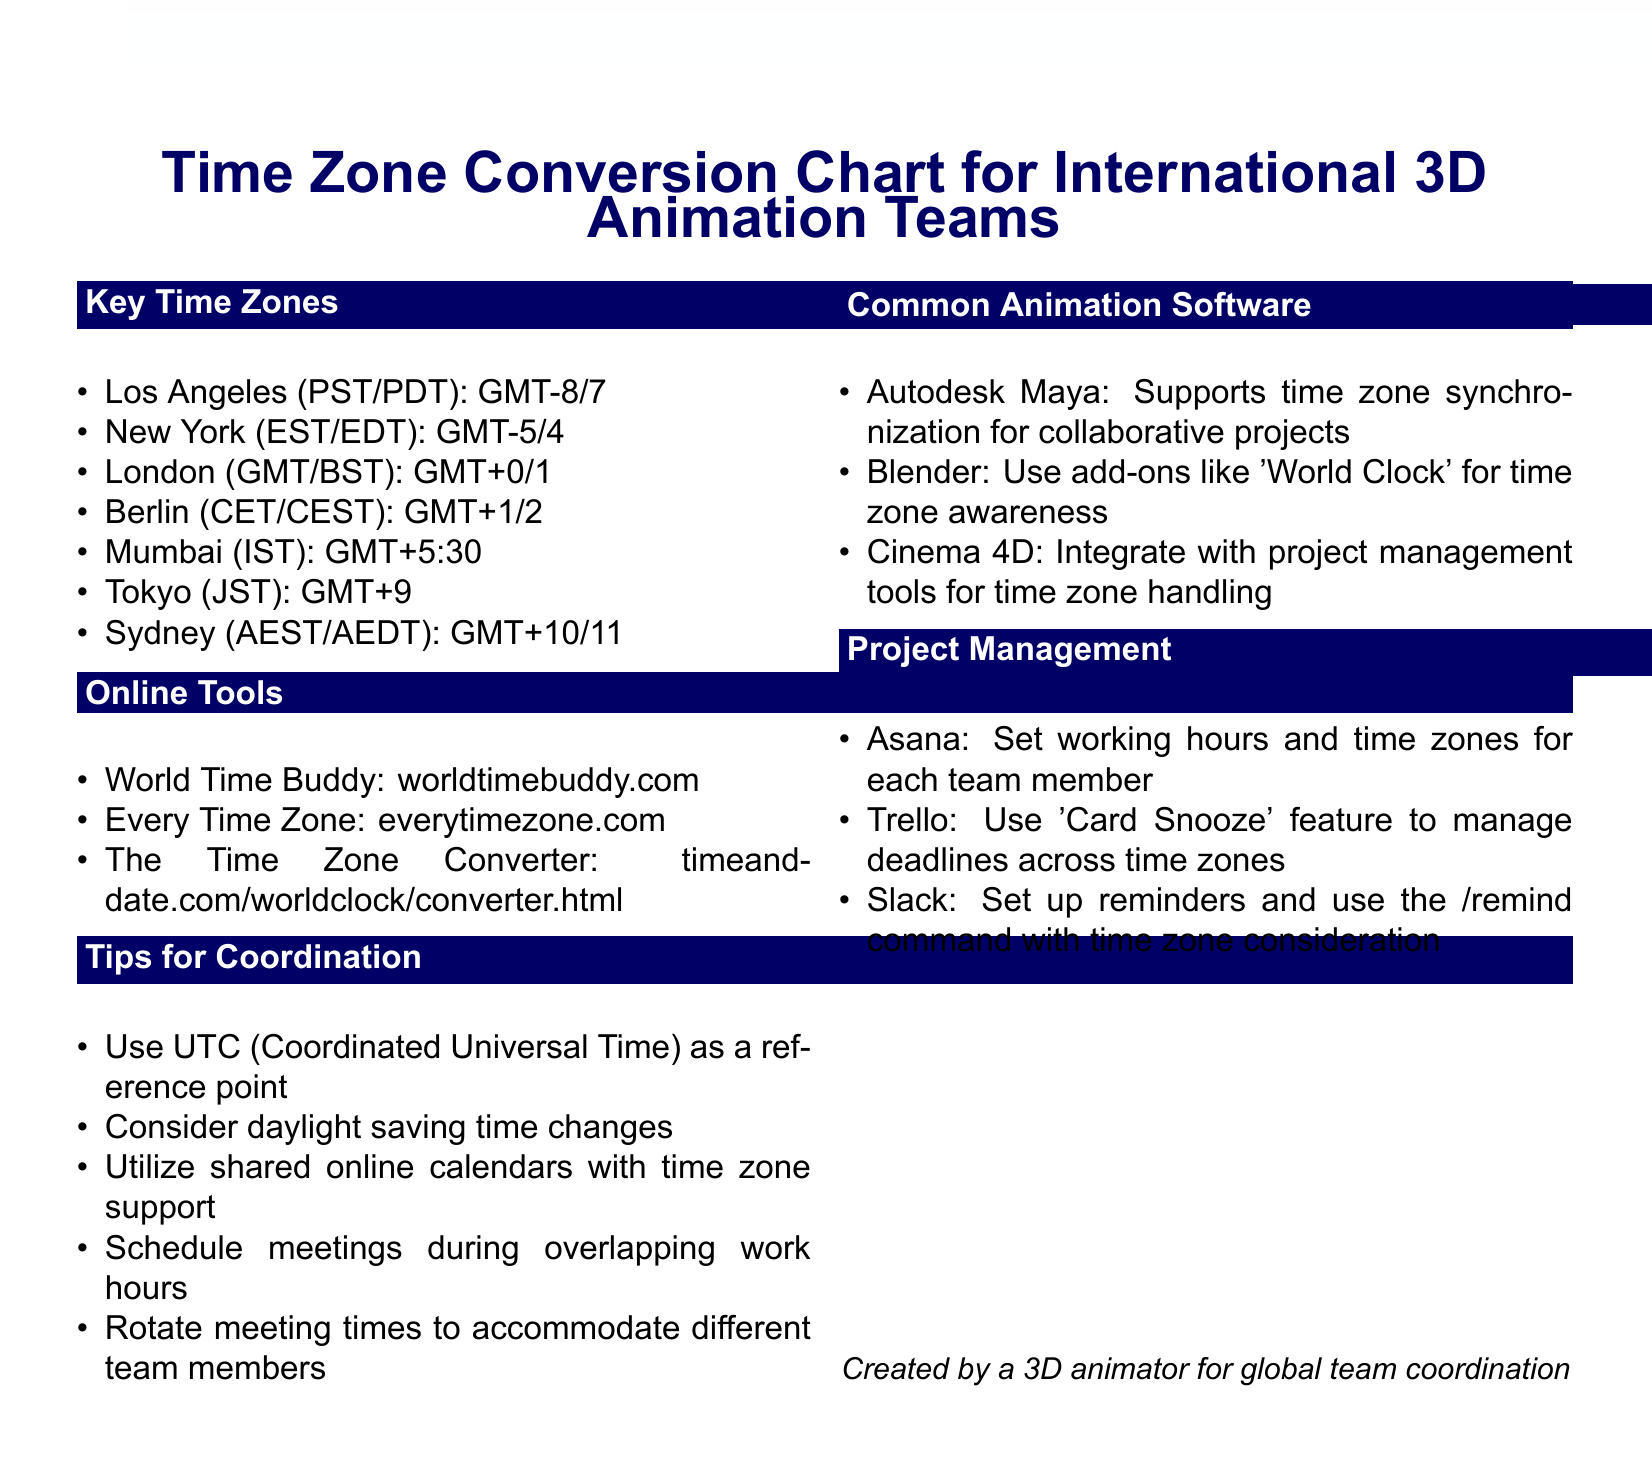What is the time zone for Los Angeles? Los Angeles is listed as PST/PDT, which corresponds to GMT-8/7.
Answer: PST/PDT What online tool allows you to convert time zones? The document lists "The Time Zone Converter" as one of the online tools for time zone conversion.
Answer: The Time Zone Converter Which city is at GMT+5:30? The document specifies that Mumbai is at GMT+5:30.
Answer: Mumbai What should be used as a reference point for scheduling? The document advises using UTC (Coordinated Universal Time) as a reference point for coordination.
Answer: UTC Which animation software supports time zone synchronization? The document states that Autodesk Maya supports time zone synchronization for collaborative projects.
Answer: Autodesk Maya What is a tip for scheduling meetings? The document suggests scheduling meetings during overlapping work hours as a tip for coordination.
Answer: Overlapping work hours Name one feature of Trello mentioned in the document. The document highlights "Card Snooze" as a feature of Trello for managing deadlines across time zones.
Answer: Card Snooze How many key time zones are listed? The document provides a list that includes seven key time zones.
Answer: Seven What should you consider regarding time zones? The document emphasizes considering daylight saving time changes in coordination efforts.
Answer: Daylight saving time changes 